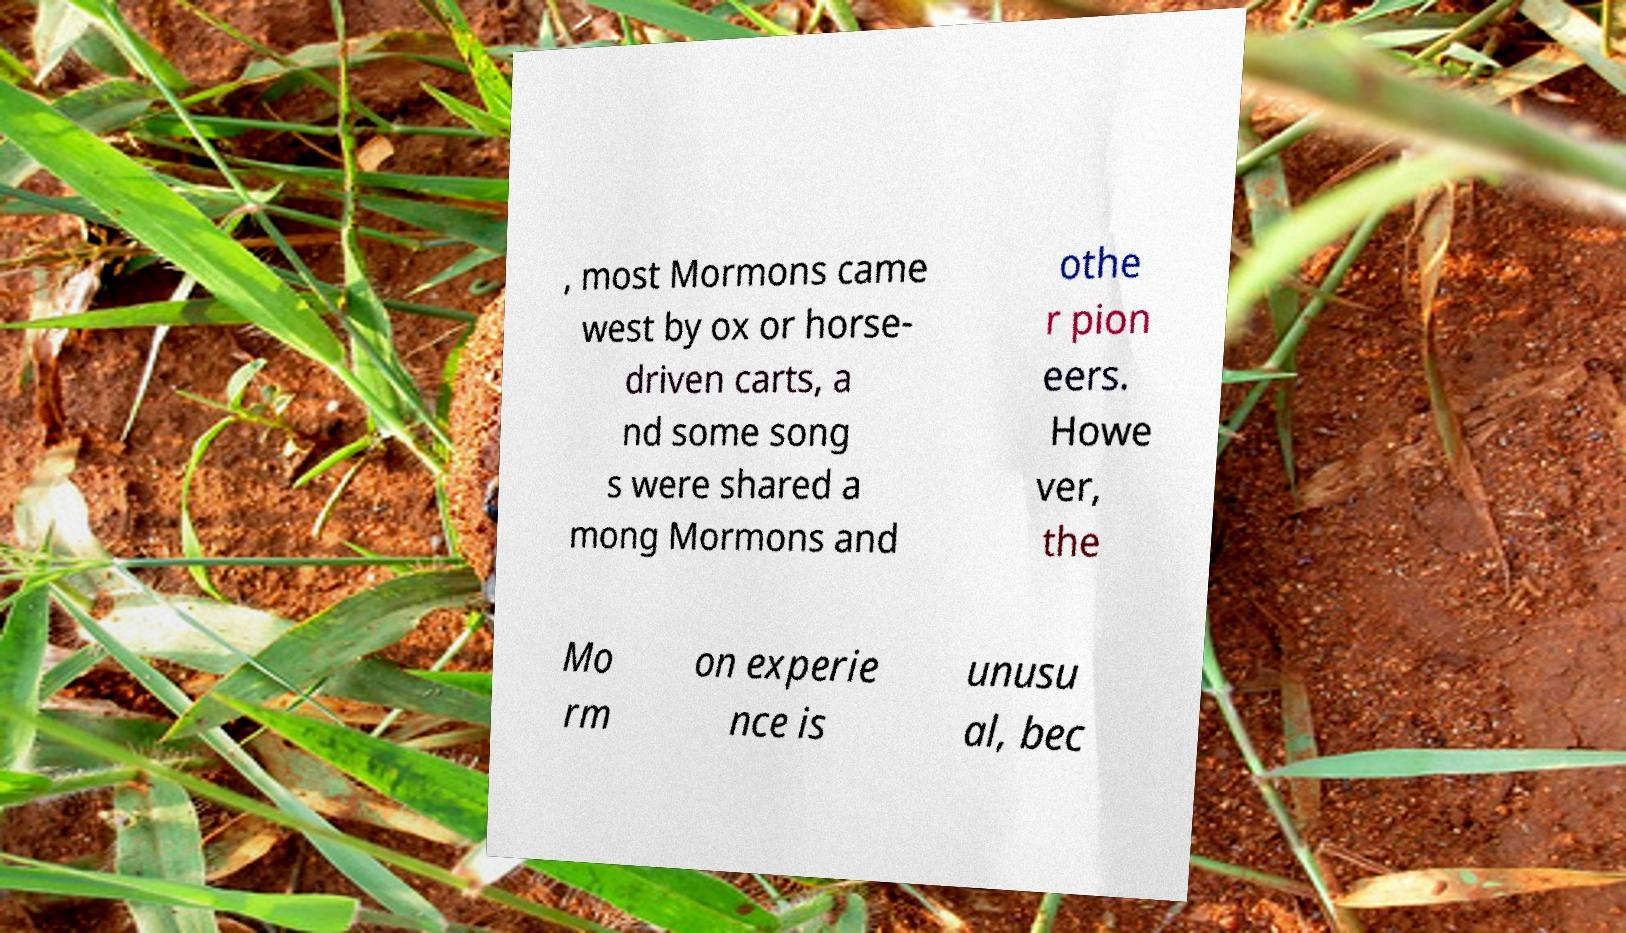There's text embedded in this image that I need extracted. Can you transcribe it verbatim? , most Mormons came west by ox or horse- driven carts, a nd some song s were shared a mong Mormons and othe r pion eers. Howe ver, the Mo rm on experie nce is unusu al, bec 